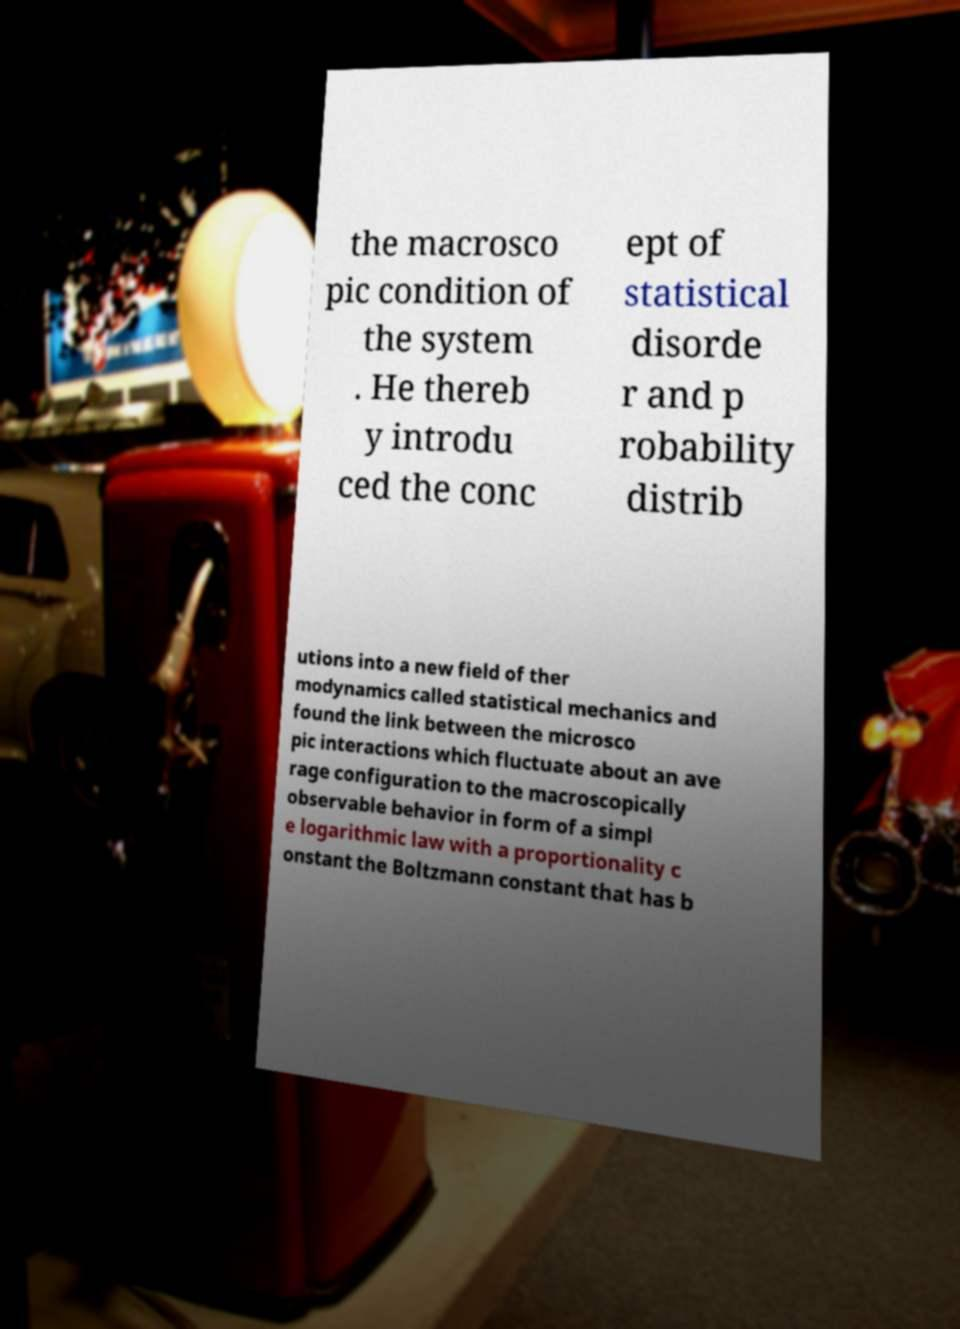Can you accurately transcribe the text from the provided image for me? the macrosco pic condition of the system . He thereb y introdu ced the conc ept of statistical disorde r and p robability distrib utions into a new field of ther modynamics called statistical mechanics and found the link between the microsco pic interactions which fluctuate about an ave rage configuration to the macroscopically observable behavior in form of a simpl e logarithmic law with a proportionality c onstant the Boltzmann constant that has b 